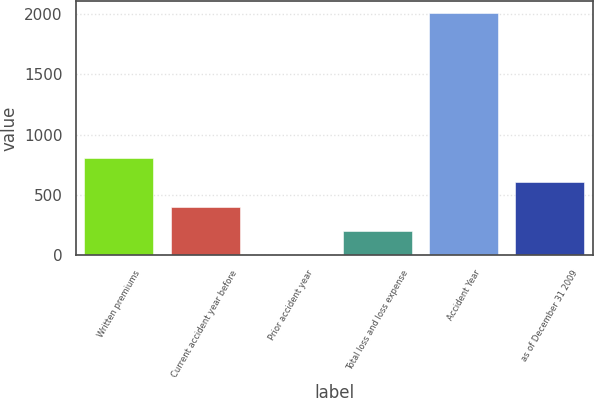Convert chart to OTSL. <chart><loc_0><loc_0><loc_500><loc_500><bar_chart><fcel>Written premiums<fcel>Current accident year before<fcel>Prior accident year<fcel>Total loss and loss expense<fcel>Accident Year<fcel>as of December 31 2009<nl><fcel>803.32<fcel>401.76<fcel>0.2<fcel>200.98<fcel>2008<fcel>602.54<nl></chart> 